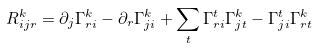Convert formula to latex. <formula><loc_0><loc_0><loc_500><loc_500>R ^ { k } _ { i j r } = \partial _ { j } \Gamma ^ { k } _ { r i } - \partial _ { r } \Gamma ^ { k } _ { j i } + \sum _ { t } \Gamma ^ { t } _ { r i } \Gamma ^ { k } _ { j t } - \Gamma ^ { t } _ { j i } \Gamma ^ { k } _ { r t }</formula> 